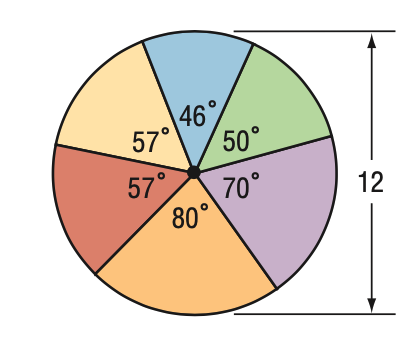Question: Find the area of the blue sector.
Choices:
A. 2.3 \pi
B. 4.6 \pi
C. 6.9 \pi
D. 9.2 \pi
Answer with the letter. Answer: B 